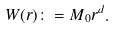Convert formula to latex. <formula><loc_0><loc_0><loc_500><loc_500>W ( r ) \colon = M _ { 0 } r ^ { d } .</formula> 